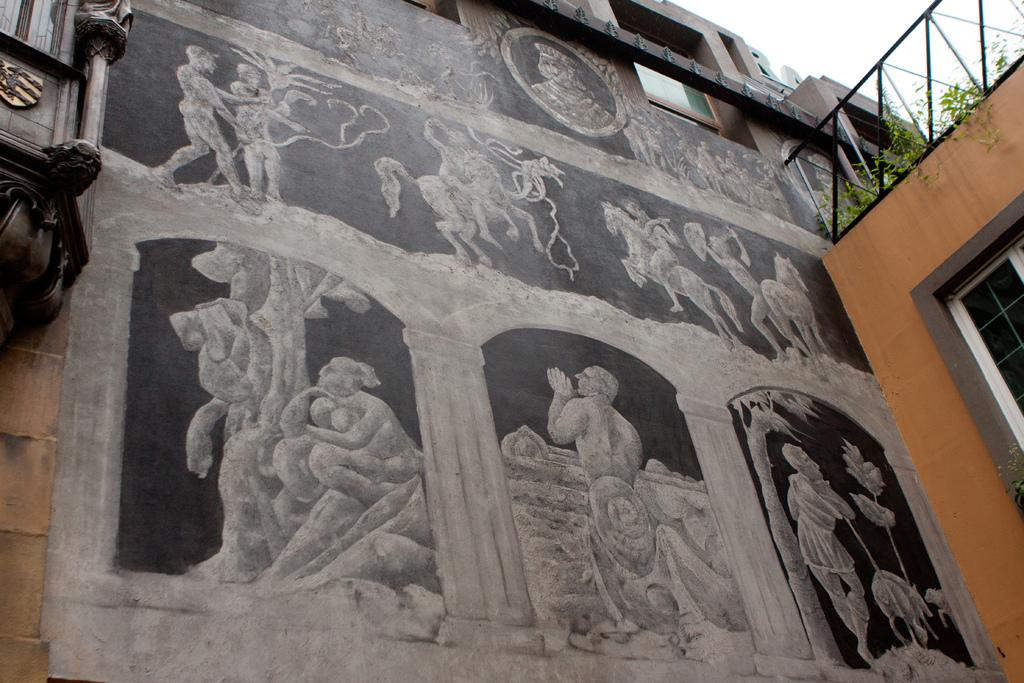What type of artwork is depicted on the wall in the image? There are paintings of statues on the wall. What can be seen on the building on the right side of the image? There are plants on the building on the right side. What type of material is the window in the image made of? The window in the image is made of glass. What is visible at the top of the image? The sky is visible at the top of the image. What type of sheet is covering the statue in the image? There is no sheet covering any statues in the image; the artwork depicts paintings of statues on the wall. What does the shame of the plants on the building suggest about their condition? There is no shame associated with the plants in the image, and the concept of shame is not relevant to the plants' condition. 